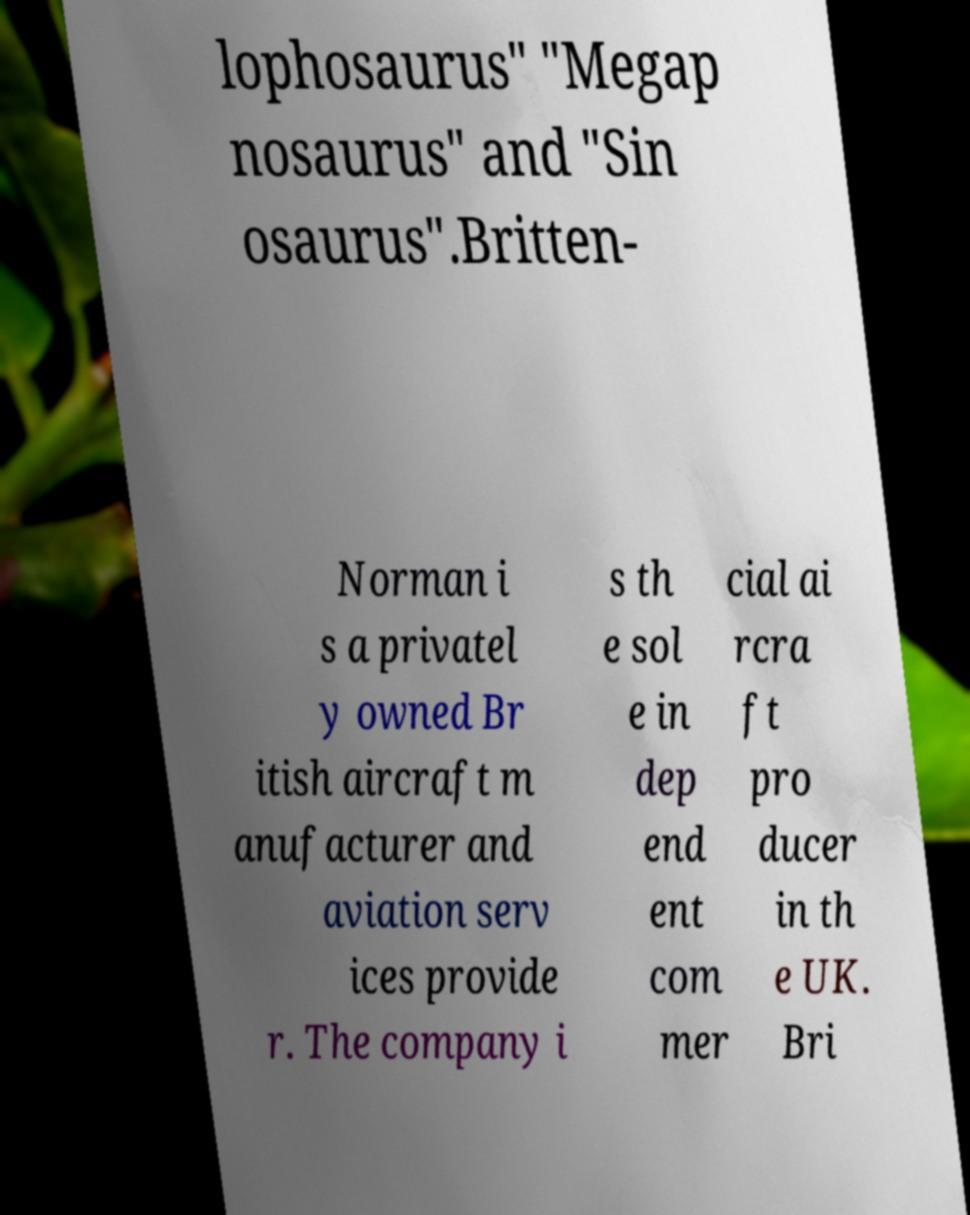There's text embedded in this image that I need extracted. Can you transcribe it verbatim? lophosaurus" "Megap nosaurus" and "Sin osaurus".Britten- Norman i s a privatel y owned Br itish aircraft m anufacturer and aviation serv ices provide r. The company i s th e sol e in dep end ent com mer cial ai rcra ft pro ducer in th e UK. Bri 